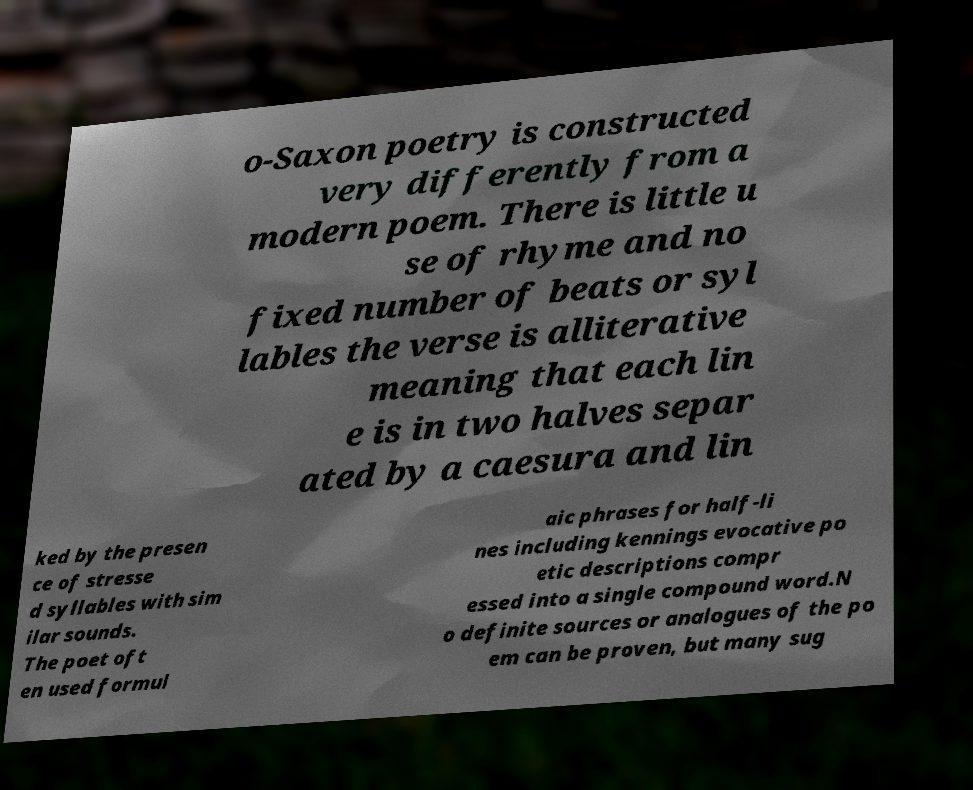Can you read and provide the text displayed in the image?This photo seems to have some interesting text. Can you extract and type it out for me? o-Saxon poetry is constructed very differently from a modern poem. There is little u se of rhyme and no fixed number of beats or syl lables the verse is alliterative meaning that each lin e is in two halves separ ated by a caesura and lin ked by the presen ce of stresse d syllables with sim ilar sounds. The poet oft en used formul aic phrases for half-li nes including kennings evocative po etic descriptions compr essed into a single compound word.N o definite sources or analogues of the po em can be proven, but many sug 